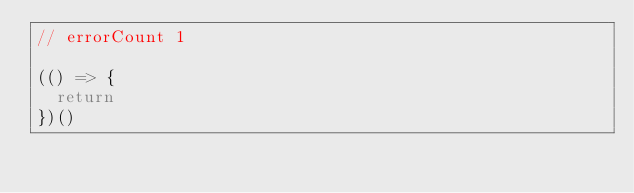<code> <loc_0><loc_0><loc_500><loc_500><_JavaScript_>// errorCount 1

(() => {
  return
})()
</code> 